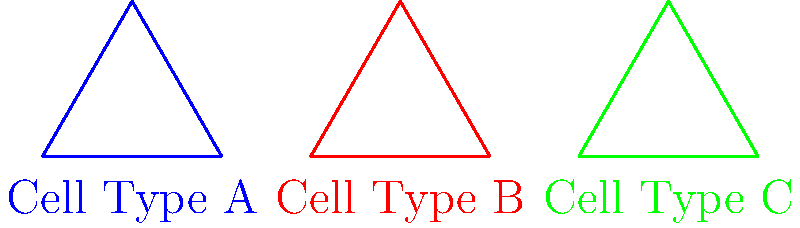In a microscopic analysis of different cancer cell types, three distinct shapes are observed as shown in the diagram. Which of these cell types are congruent to each other? To determine if the shapes representing different cancer cell types are congruent, we need to follow these steps:

1. Recall that congruent shapes have the same size and shape, meaning all corresponding sides and angles are equal.

2. Observe the three triangles in the diagram:
   - Cell Type A: Blue triangle
   - Cell Type B: Red triangle
   - Cell Type C: Green triangle

3. Compare the triangles:
   - All three triangles appear to be equilateral triangles (all sides and angles are equal within each triangle).
   - The triangles are the same size, as they all have the same base length (2 units) and height.
   - The triangles are in the same orientation, although positioned differently on the plane.

4. Based on these observations, we can conclude that all three triangles are congruent to each other.

5. In the context of cancer cells, this could represent that these three cell types have similar geometric properties when viewed under a microscope, despite being from different cancer types.
Answer: All three cell types (A, B, and C) are congruent. 